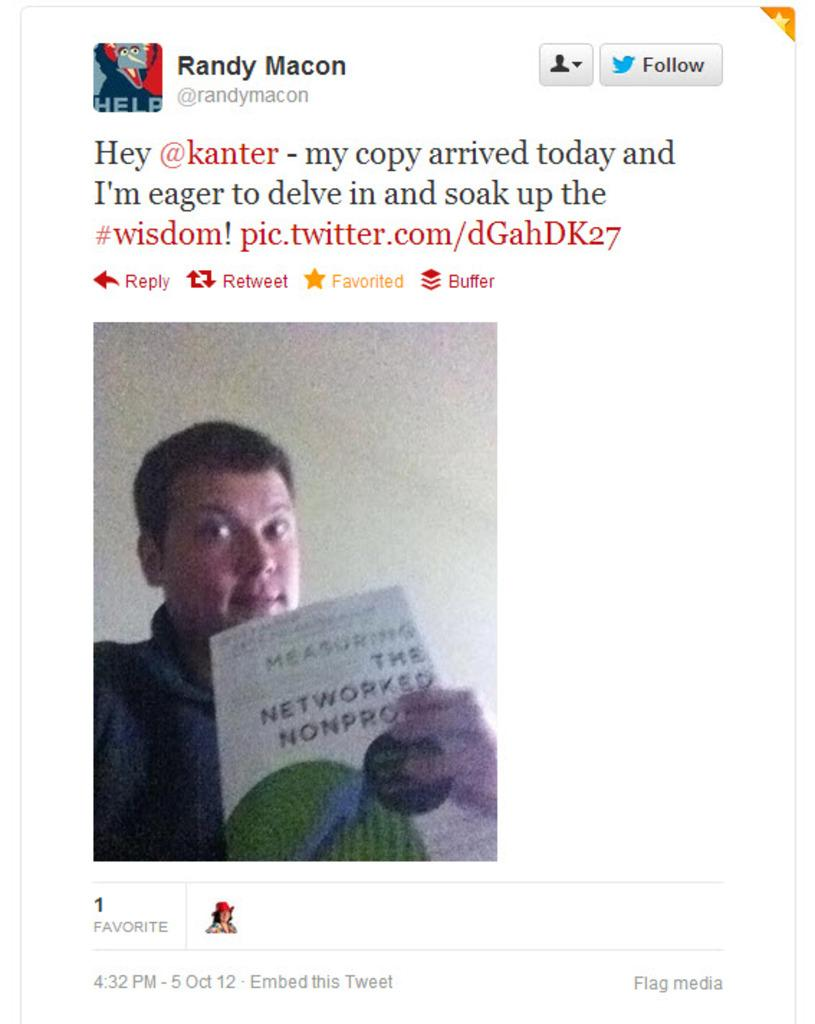What type of image is shown in the screenshot? The image is a screenshot. What is the person in the image holding? The person in the image is holding a newspaper in their hand. What additional information can be seen at the top of the screenshot? There is text visible at the top of the screenshot. What color is the coat worn by the bee in the image? There is no bee present in the image, and therefore no coat to describe. 